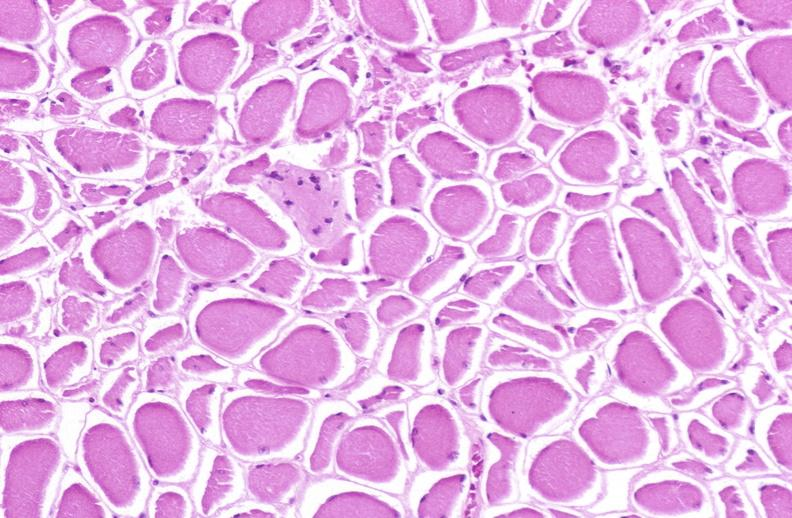what is present?
Answer the question using a single word or phrase. Soft tissue 